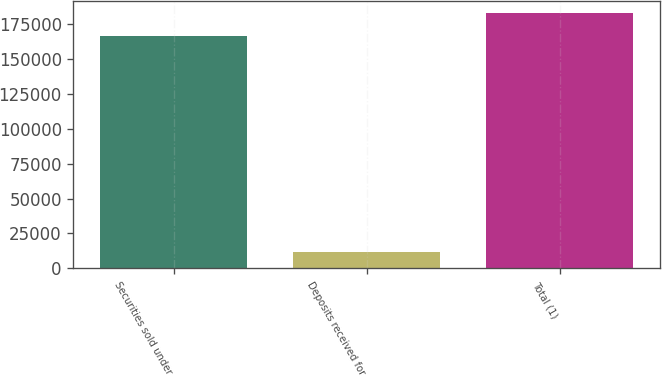Convert chart. <chart><loc_0><loc_0><loc_500><loc_500><bar_chart><fcel>Securities sold under<fcel>Deposits received for<fcel>Total (1)<nl><fcel>166090<fcel>11678<fcel>182699<nl></chart> 